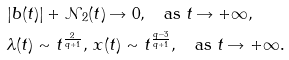<formula> <loc_0><loc_0><loc_500><loc_500>& | b ( t ) | + \mathcal { N } _ { 2 } ( t ) \rightarrow 0 , \quad \text {as } t \rightarrow + \infty , \\ & \lambda ( t ) \sim t ^ { \frac { 2 } { q + 1 } } , \, x ( t ) \sim t ^ { \frac { q - 3 } { q + 1 } } , \quad \text {as } t \rightarrow + \infty .</formula> 